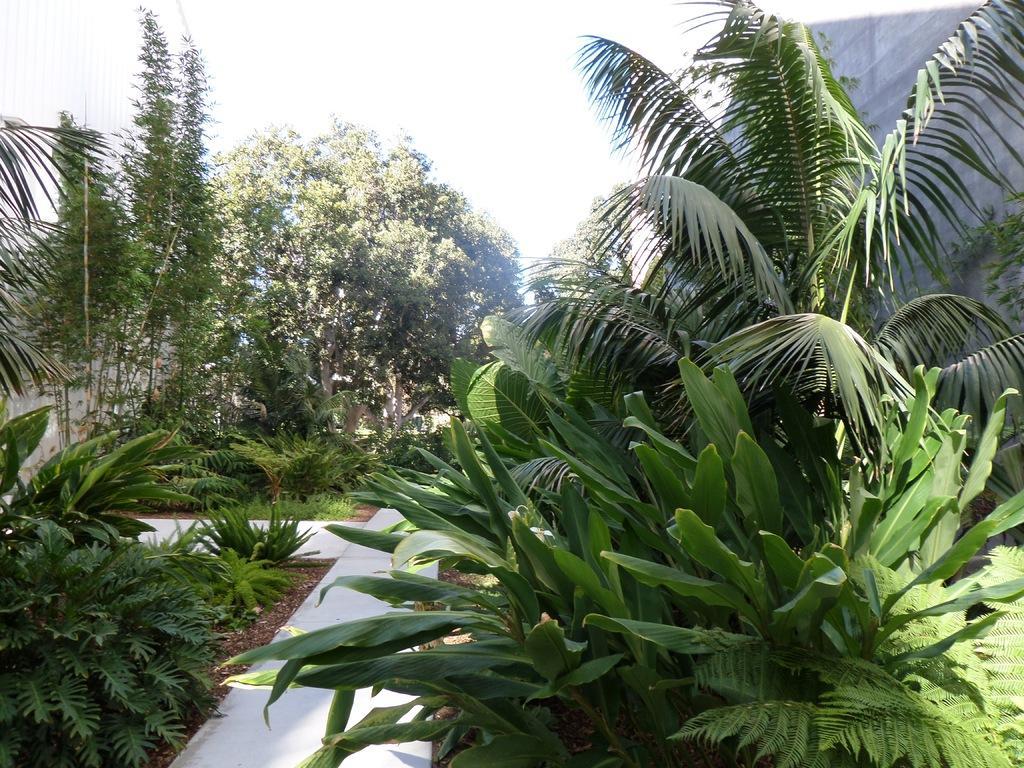Describe this image in one or two sentences. In this picture we can see few trees beside the pathway. 